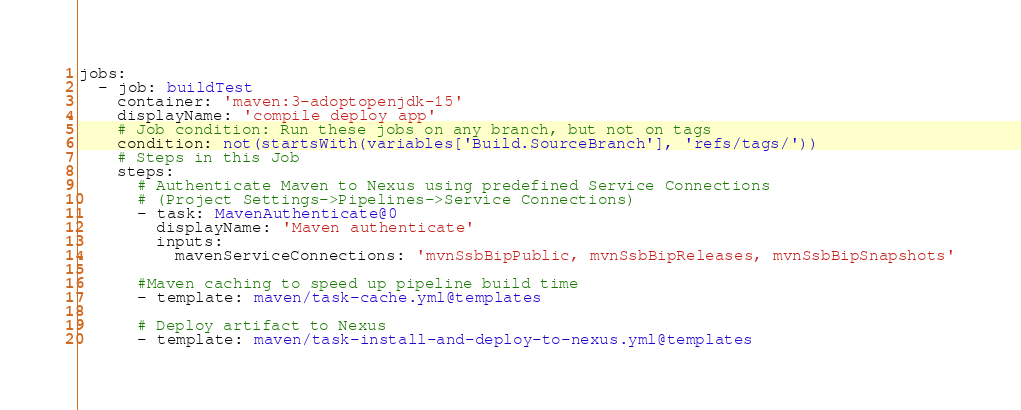Convert code to text. <code><loc_0><loc_0><loc_500><loc_500><_YAML_>jobs:
  - job: buildTest
    container: 'maven:3-adoptopenjdk-15'
    displayName: 'compile deploy app'
    # Job condition: Run these jobs on any branch, but not on tags
    condition: not(startsWith(variables['Build.SourceBranch'], 'refs/tags/'))
    # Steps in this Job
    steps:
      # Authenticate Maven to Nexus using predefined Service Connections
      # (Project Settings->Pipelines->Service Connections)
      - task: MavenAuthenticate@0
        displayName: 'Maven authenticate'
        inputs:
          mavenServiceConnections: 'mvnSsbBipPublic, mvnSsbBipReleases, mvnSsbBipSnapshots'

      #Maven caching to speed up pipeline build time
      - template: maven/task-cache.yml@templates

      # Deploy artifact to Nexus
      - template: maven/task-install-and-deploy-to-nexus.yml@templates</code> 